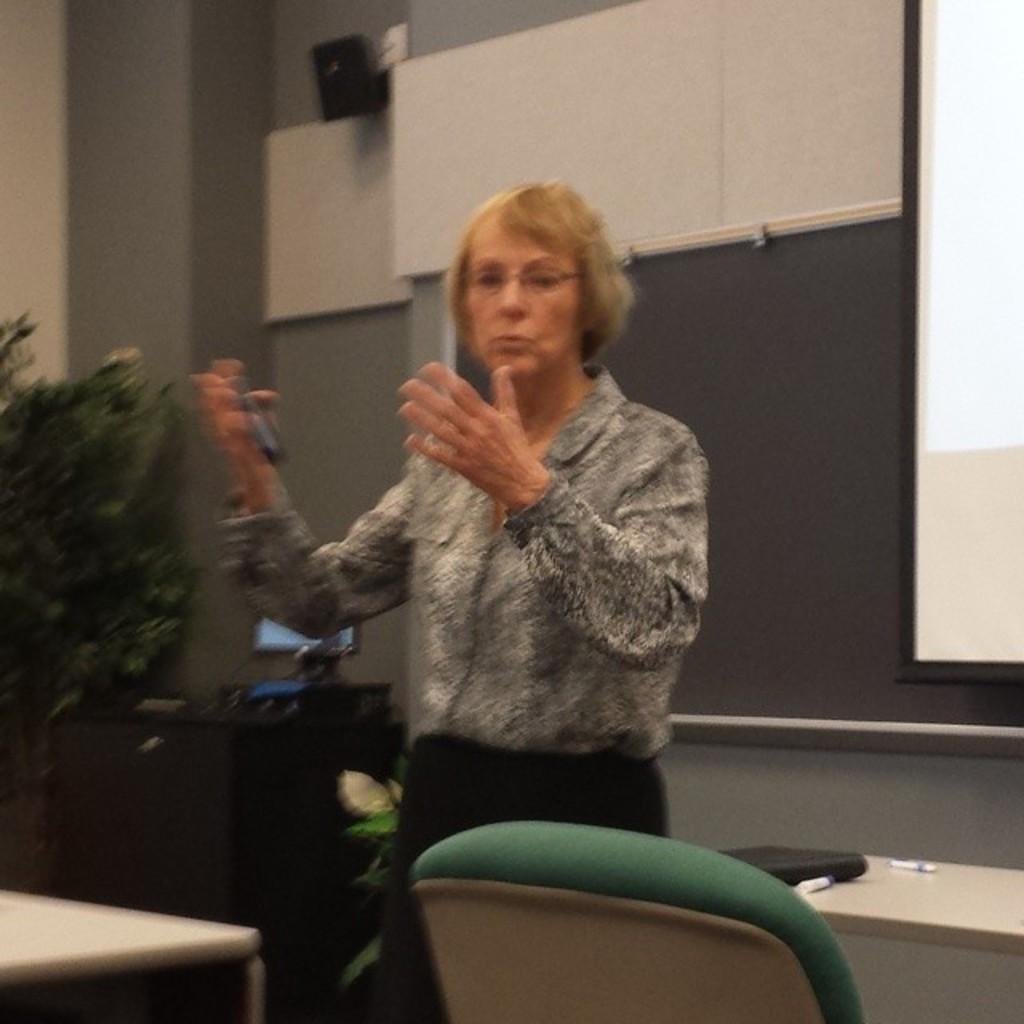In one or two sentences, can you explain what this image depicts? In this picture we can see a woman is standing and holding something in her hand, and at back here is the table and some objects on it, and at back here is the board, and here is the tree. 